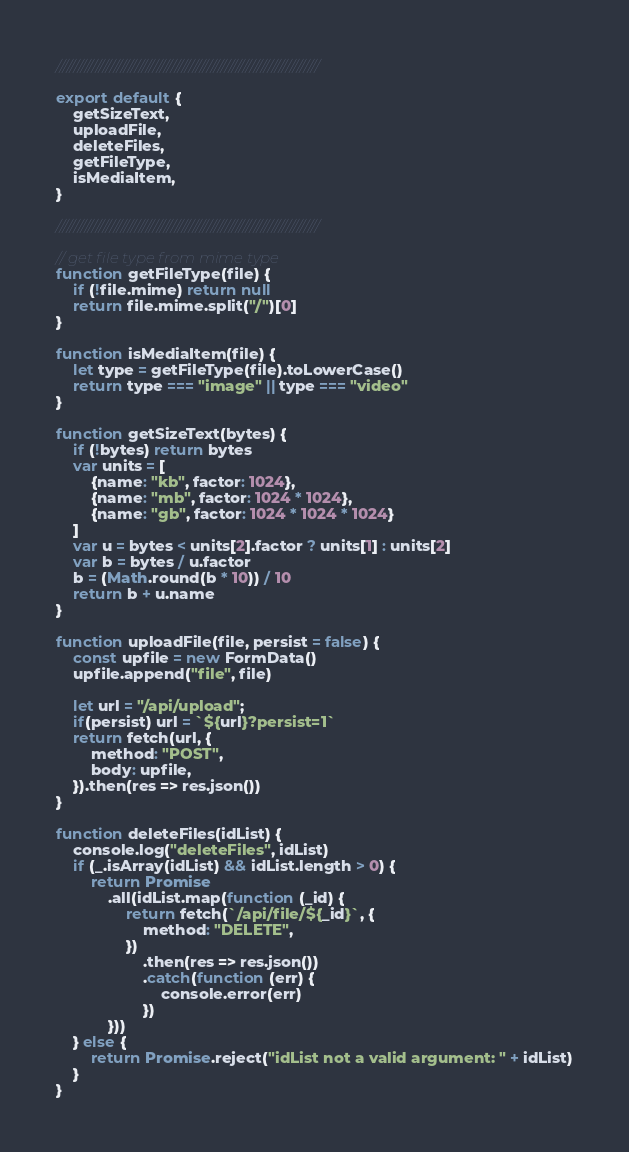Convert code to text. <code><loc_0><loc_0><loc_500><loc_500><_JavaScript_>/////////////////////////////////////////////////////////////////////////

export default {
    getSizeText,
    uploadFile,
    deleteFiles,
    getFileType,
    isMediaItem,
}

/////////////////////////////////////////////////////////////////////////

// get file type from mime type
function getFileType(file) {
    if (!file.mime) return null
    return file.mime.split("/")[0]
}

function isMediaItem(file) {
    let type = getFileType(file).toLowerCase()
    return type === "image" || type === "video"
}

function getSizeText(bytes) {
    if (!bytes) return bytes
    var units = [
        {name: "kb", factor: 1024},
        {name: "mb", factor: 1024 * 1024},
        {name: "gb", factor: 1024 * 1024 * 1024}
    ]
    var u = bytes < units[2].factor ? units[1] : units[2]
    var b = bytes / u.factor
    b = (Math.round(b * 10)) / 10
    return b + u.name
}

function uploadFile(file, persist = false) {
    const upfile = new FormData()
    upfile.append("file", file)

    let url = "/api/upload";
    if(persist) url = `${url}?persist=1`
    return fetch(url, {
        method: "POST",
        body: upfile,
    }).then(res => res.json())
}

function deleteFiles(idList) {
    console.log("deleteFiles", idList)
    if (_.isArray(idList) && idList.length > 0) {
        return Promise
            .all(idList.map(function (_id) {
                return fetch(`/api/file/${_id}`, {
                    method: "DELETE",
                })
                    .then(res => res.json())
                    .catch(function (err) {
                        console.error(err)
                    })
            }))
    } else {
        return Promise.reject("idList not a valid argument: " + idList)
    }
}
</code> 